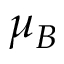<formula> <loc_0><loc_0><loc_500><loc_500>\mu _ { B }</formula> 